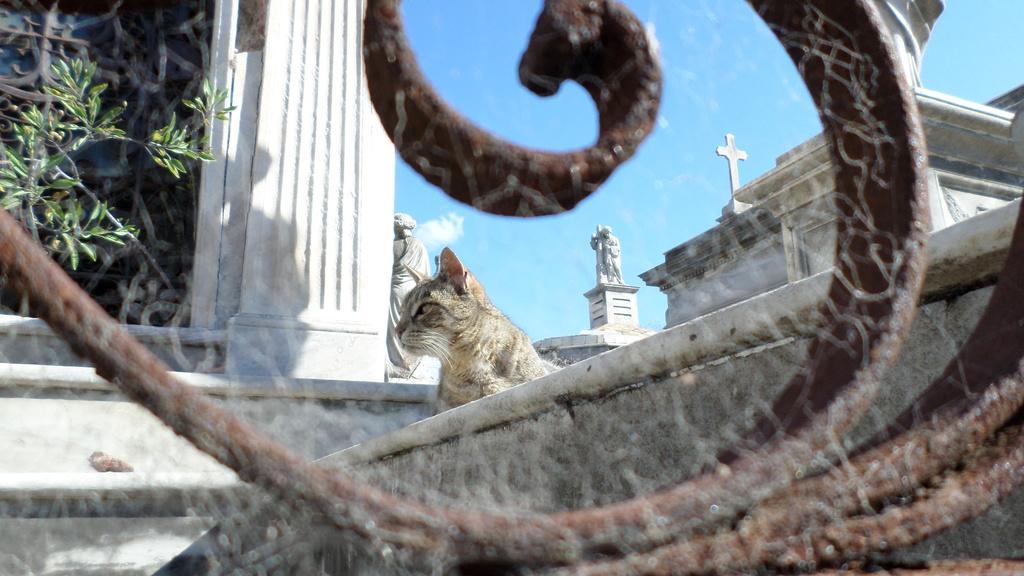How would you summarize this image in a sentence or two? In this image in the front there is an object which is brown in colour. In the center there is a cat. In the background there are statues, there is a plant and there is a wall. 